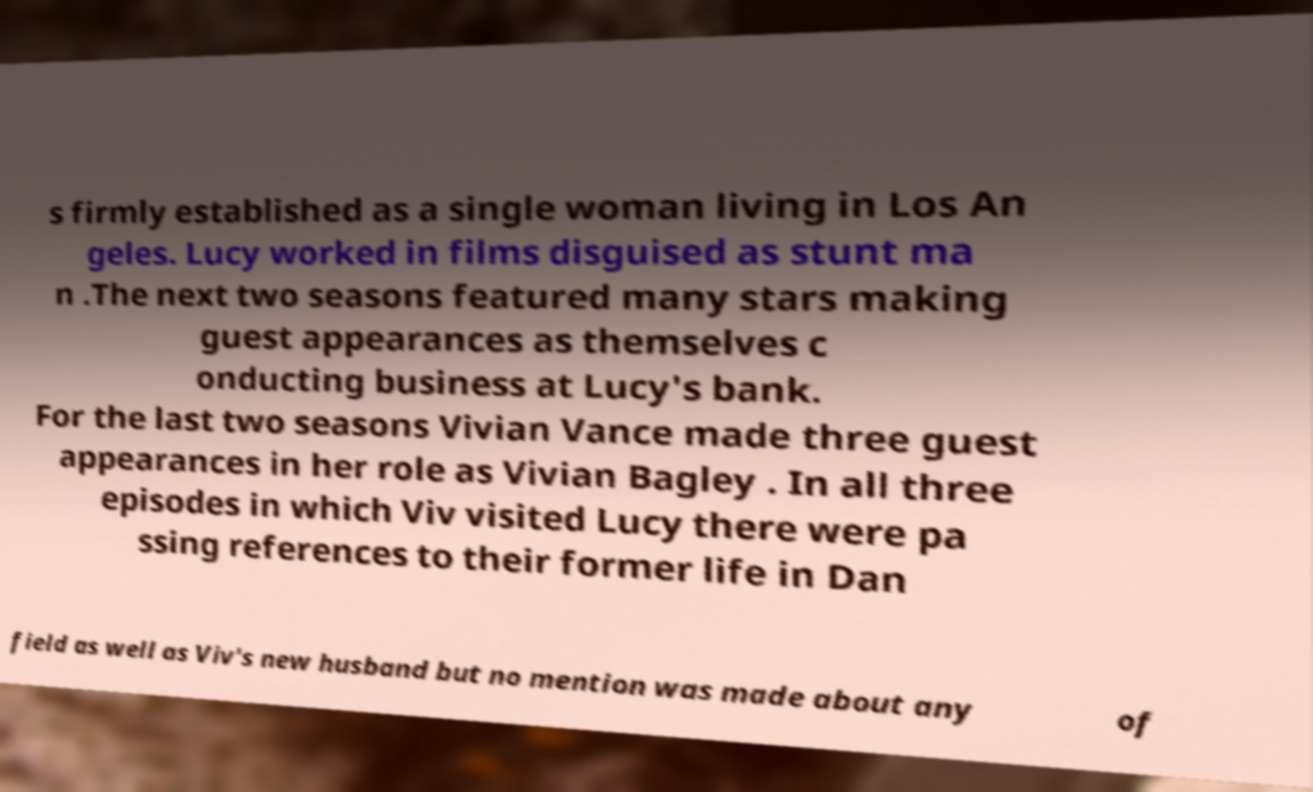Can you read and provide the text displayed in the image?This photo seems to have some interesting text. Can you extract and type it out for me? s firmly established as a single woman living in Los An geles. Lucy worked in films disguised as stunt ma n .The next two seasons featured many stars making guest appearances as themselves c onducting business at Lucy's bank. For the last two seasons Vivian Vance made three guest appearances in her role as Vivian Bagley . In all three episodes in which Viv visited Lucy there were pa ssing references to their former life in Dan field as well as Viv's new husband but no mention was made about any of 